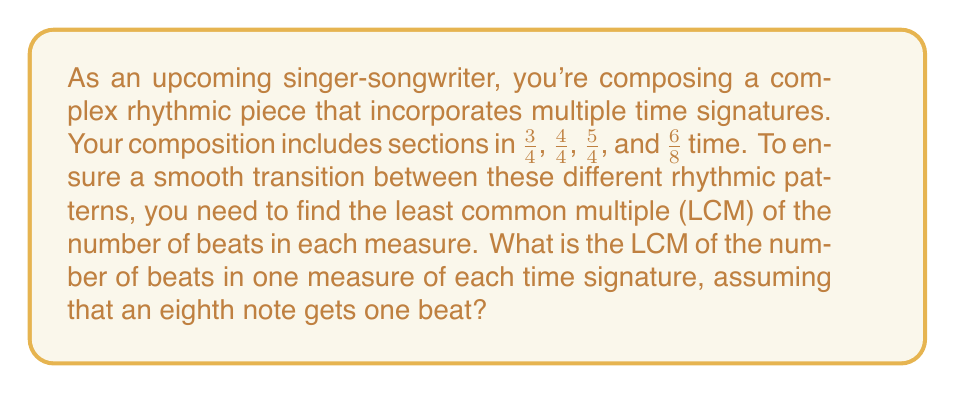Can you answer this question? To solve this problem, we need to follow these steps:

1. Convert all time signatures to eighth note beats per measure:
   - 3/4 = 6 eighth notes per measure
   - 4/4 = 8 eighth notes per measure
   - 5/4 = 10 eighth notes per measure
   - 6/8 = 6 eighth notes per measure

2. Find the LCM of 6, 8, 10, and 6:
   
   First, let's factor each number:
   $$6 = 2 \times 3$$
   $$8 = 2^3$$
   $$10 = 2 \times 5$$
   
   The LCM will include the highest power of each prime factor:
   $$LCM = 2^3 \times 3 \times 5$$

3. Calculate the result:
   $$LCM = 8 \times 3 \times 5 = 120$$

Therefore, the least common multiple of the number of eighth note beats in one measure of each time signature is 120 eighth notes.

This means that every 120 eighth notes (or 60 quarter notes), all time signatures will align, creating a natural cycle in your composition.
Answer: The least common multiple (LCM) of the number of beats in one measure of each time signature (3/4, 4/4, 5/4, and 6/8) is 120 eighth notes. 